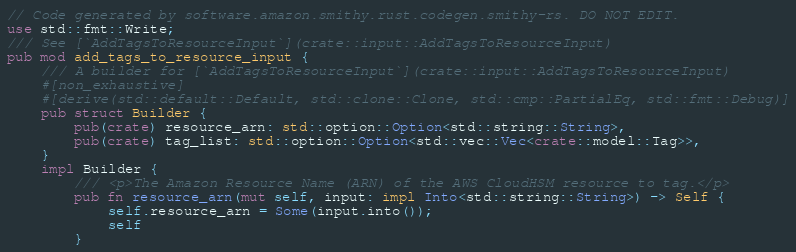<code> <loc_0><loc_0><loc_500><loc_500><_Rust_>// Code generated by software.amazon.smithy.rust.codegen.smithy-rs. DO NOT EDIT.
use std::fmt::Write;
/// See [`AddTagsToResourceInput`](crate::input::AddTagsToResourceInput)
pub mod add_tags_to_resource_input {
    /// A builder for [`AddTagsToResourceInput`](crate::input::AddTagsToResourceInput)
    #[non_exhaustive]
    #[derive(std::default::Default, std::clone::Clone, std::cmp::PartialEq, std::fmt::Debug)]
    pub struct Builder {
        pub(crate) resource_arn: std::option::Option<std::string::String>,
        pub(crate) tag_list: std::option::Option<std::vec::Vec<crate::model::Tag>>,
    }
    impl Builder {
        /// <p>The Amazon Resource Name (ARN) of the AWS CloudHSM resource to tag.</p>
        pub fn resource_arn(mut self, input: impl Into<std::string::String>) -> Self {
            self.resource_arn = Some(input.into());
            self
        }</code> 